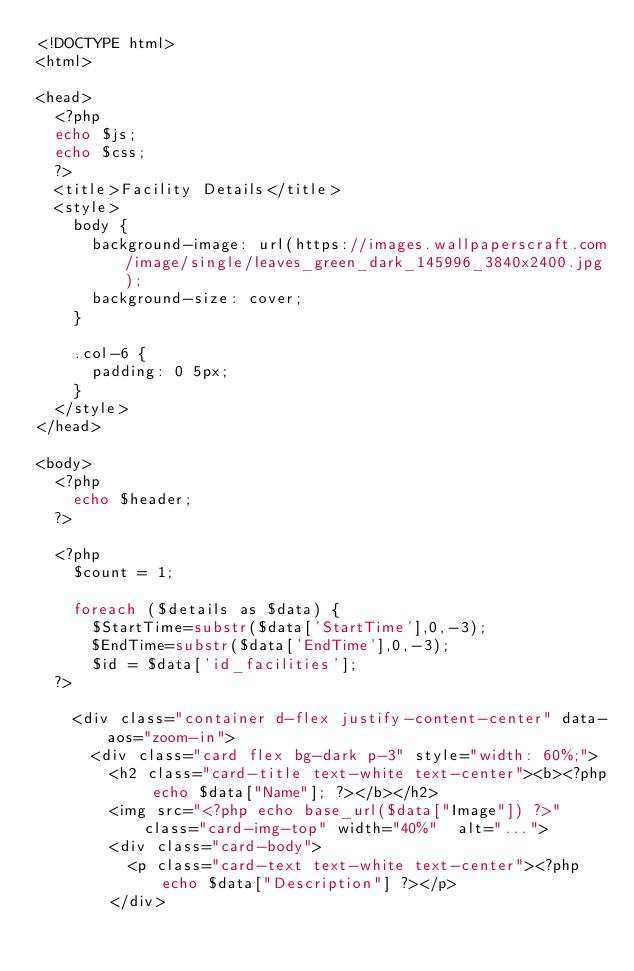<code> <loc_0><loc_0><loc_500><loc_500><_PHP_><!DOCTYPE html>
<html>

<head>
  <?php
  echo $js;
  echo $css;
  ?>
  <title>Facility Details</title>
  <style>
    body {
      background-image: url(https://images.wallpaperscraft.com/image/single/leaves_green_dark_145996_3840x2400.jpg);
      background-size: cover;
    }

    .col-6 {
      padding: 0 5px;
    }
  </style>
</head>

<body>
  <?php
    echo $header;
  ?>

  <?php
    $count = 1;

    foreach ($details as $data) {
      $StartTime=substr($data['StartTime'],0,-3);
      $EndTime=substr($data['EndTime'],0,-3);
      $id = $data['id_facilities'];
  ?>

    <div class="container d-flex justify-content-center" data-aos="zoom-in">
      <div class="card flex bg-dark p-3" style="width: 60%;">
        <h2 class="card-title text-white text-center"><b><?php echo $data["Name"]; ?></b></h2>
        <img src="<?php echo base_url($data["Image"]) ?>" class="card-img-top" width="40%"  alt="...">
        <div class="card-body">
          <p class="card-text text-white text-center"><?php echo $data["Description"] ?></p>
        </div></code> 